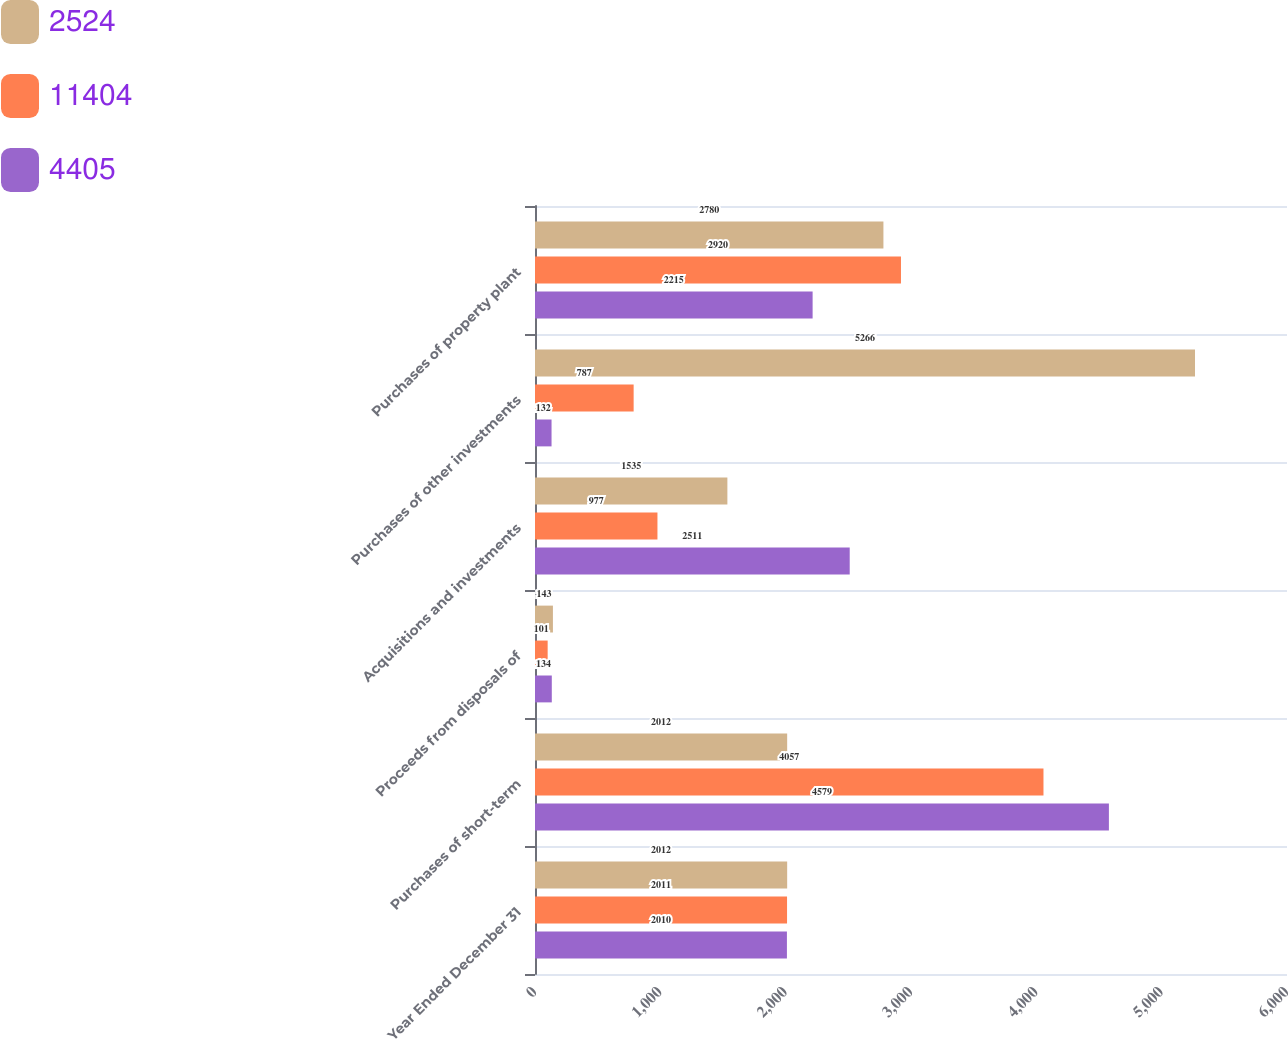Convert chart to OTSL. <chart><loc_0><loc_0><loc_500><loc_500><stacked_bar_chart><ecel><fcel>Year Ended December 31<fcel>Purchases of short-term<fcel>Proceeds from disposals of<fcel>Acquisitions and investments<fcel>Purchases of other investments<fcel>Purchases of property plant<nl><fcel>2524<fcel>2012<fcel>2012<fcel>143<fcel>1535<fcel>5266<fcel>2780<nl><fcel>11404<fcel>2011<fcel>4057<fcel>101<fcel>977<fcel>787<fcel>2920<nl><fcel>4405<fcel>2010<fcel>4579<fcel>134<fcel>2511<fcel>132<fcel>2215<nl></chart> 